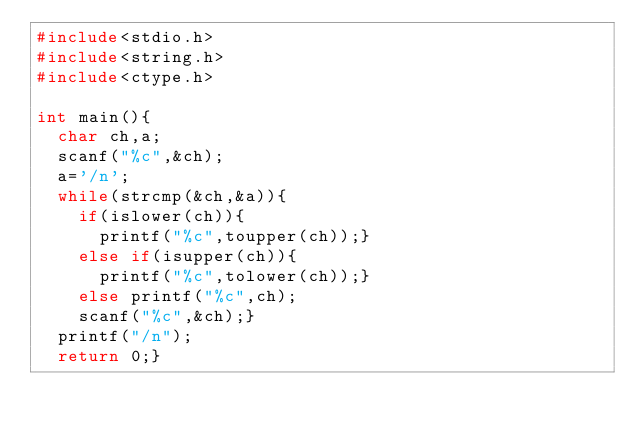<code> <loc_0><loc_0><loc_500><loc_500><_C_>#include<stdio.h>
#include<string.h>
#include<ctype.h>

int main(){
  char ch,a;
  scanf("%c",&ch);
  a='/n';
  while(strcmp(&ch,&a)){
    if(islower(ch)){
      printf("%c",toupper(ch));}
    else if(isupper(ch)){
      printf("%c",tolower(ch));}
    else printf("%c",ch);
    scanf("%c",&ch);}
  printf("/n");
  return 0;}</code> 